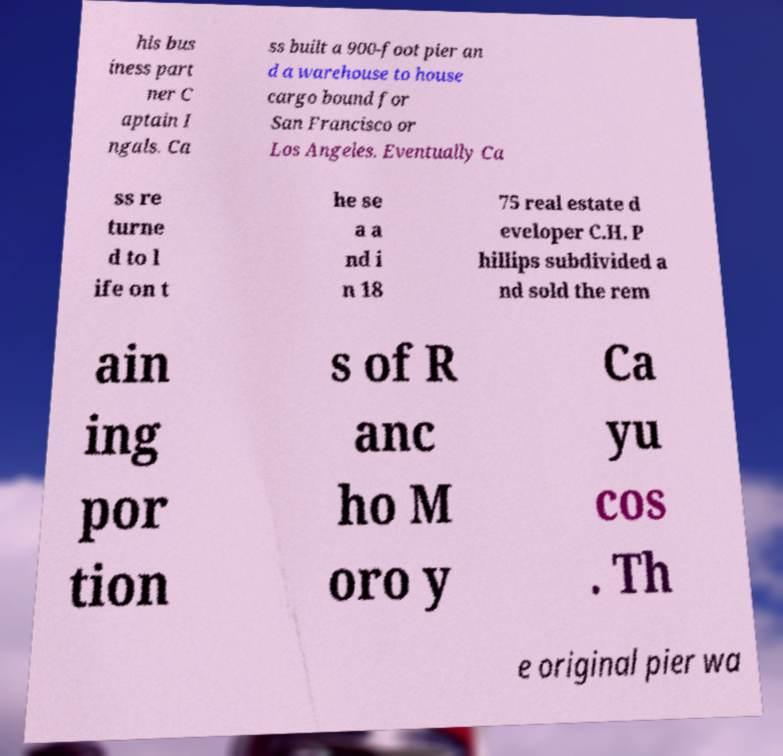What messages or text are displayed in this image? I need them in a readable, typed format. his bus iness part ner C aptain I ngals. Ca ss built a 900-foot pier an d a warehouse to house cargo bound for San Francisco or Los Angeles. Eventually Ca ss re turne d to l ife on t he se a a nd i n 18 75 real estate d eveloper C.H. P hillips subdivided a nd sold the rem ain ing por tion s of R anc ho M oro y Ca yu cos . Th e original pier wa 